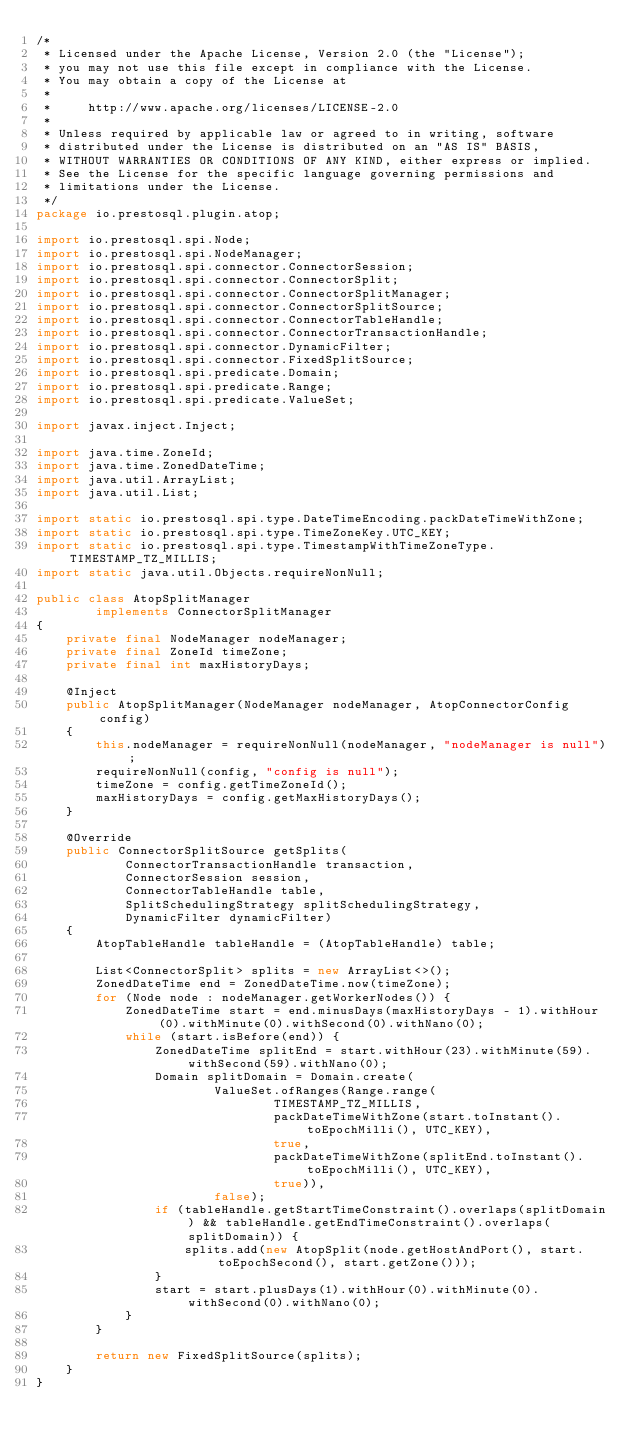Convert code to text. <code><loc_0><loc_0><loc_500><loc_500><_Java_>/*
 * Licensed under the Apache License, Version 2.0 (the "License");
 * you may not use this file except in compliance with the License.
 * You may obtain a copy of the License at
 *
 *     http://www.apache.org/licenses/LICENSE-2.0
 *
 * Unless required by applicable law or agreed to in writing, software
 * distributed under the License is distributed on an "AS IS" BASIS,
 * WITHOUT WARRANTIES OR CONDITIONS OF ANY KIND, either express or implied.
 * See the License for the specific language governing permissions and
 * limitations under the License.
 */
package io.prestosql.plugin.atop;

import io.prestosql.spi.Node;
import io.prestosql.spi.NodeManager;
import io.prestosql.spi.connector.ConnectorSession;
import io.prestosql.spi.connector.ConnectorSplit;
import io.prestosql.spi.connector.ConnectorSplitManager;
import io.prestosql.spi.connector.ConnectorSplitSource;
import io.prestosql.spi.connector.ConnectorTableHandle;
import io.prestosql.spi.connector.ConnectorTransactionHandle;
import io.prestosql.spi.connector.DynamicFilter;
import io.prestosql.spi.connector.FixedSplitSource;
import io.prestosql.spi.predicate.Domain;
import io.prestosql.spi.predicate.Range;
import io.prestosql.spi.predicate.ValueSet;

import javax.inject.Inject;

import java.time.ZoneId;
import java.time.ZonedDateTime;
import java.util.ArrayList;
import java.util.List;

import static io.prestosql.spi.type.DateTimeEncoding.packDateTimeWithZone;
import static io.prestosql.spi.type.TimeZoneKey.UTC_KEY;
import static io.prestosql.spi.type.TimestampWithTimeZoneType.TIMESTAMP_TZ_MILLIS;
import static java.util.Objects.requireNonNull;

public class AtopSplitManager
        implements ConnectorSplitManager
{
    private final NodeManager nodeManager;
    private final ZoneId timeZone;
    private final int maxHistoryDays;

    @Inject
    public AtopSplitManager(NodeManager nodeManager, AtopConnectorConfig config)
    {
        this.nodeManager = requireNonNull(nodeManager, "nodeManager is null");
        requireNonNull(config, "config is null");
        timeZone = config.getTimeZoneId();
        maxHistoryDays = config.getMaxHistoryDays();
    }

    @Override
    public ConnectorSplitSource getSplits(
            ConnectorTransactionHandle transaction,
            ConnectorSession session,
            ConnectorTableHandle table,
            SplitSchedulingStrategy splitSchedulingStrategy,
            DynamicFilter dynamicFilter)
    {
        AtopTableHandle tableHandle = (AtopTableHandle) table;

        List<ConnectorSplit> splits = new ArrayList<>();
        ZonedDateTime end = ZonedDateTime.now(timeZone);
        for (Node node : nodeManager.getWorkerNodes()) {
            ZonedDateTime start = end.minusDays(maxHistoryDays - 1).withHour(0).withMinute(0).withSecond(0).withNano(0);
            while (start.isBefore(end)) {
                ZonedDateTime splitEnd = start.withHour(23).withMinute(59).withSecond(59).withNano(0);
                Domain splitDomain = Domain.create(
                        ValueSet.ofRanges(Range.range(
                                TIMESTAMP_TZ_MILLIS,
                                packDateTimeWithZone(start.toInstant().toEpochMilli(), UTC_KEY),
                                true,
                                packDateTimeWithZone(splitEnd.toInstant().toEpochMilli(), UTC_KEY),
                                true)),
                        false);
                if (tableHandle.getStartTimeConstraint().overlaps(splitDomain) && tableHandle.getEndTimeConstraint().overlaps(splitDomain)) {
                    splits.add(new AtopSplit(node.getHostAndPort(), start.toEpochSecond(), start.getZone()));
                }
                start = start.plusDays(1).withHour(0).withMinute(0).withSecond(0).withNano(0);
            }
        }

        return new FixedSplitSource(splits);
    }
}
</code> 